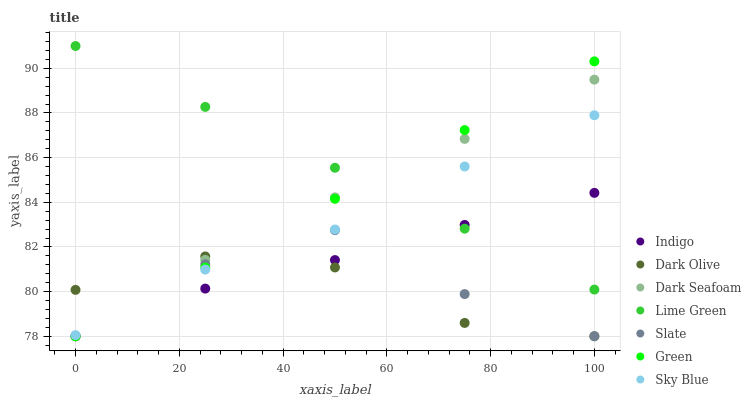Does Dark Olive have the minimum area under the curve?
Answer yes or no. Yes. Does Lime Green have the maximum area under the curve?
Answer yes or no. Yes. Does Slate have the minimum area under the curve?
Answer yes or no. No. Does Slate have the maximum area under the curve?
Answer yes or no. No. Is Green the smoothest?
Answer yes or no. Yes. Is Slate the roughest?
Answer yes or no. Yes. Is Dark Olive the smoothest?
Answer yes or no. No. Is Dark Olive the roughest?
Answer yes or no. No. Does Indigo have the lowest value?
Answer yes or no. Yes. Does Sky Blue have the lowest value?
Answer yes or no. No. Does Lime Green have the highest value?
Answer yes or no. Yes. Does Slate have the highest value?
Answer yes or no. No. Is Slate less than Lime Green?
Answer yes or no. Yes. Is Lime Green greater than Dark Olive?
Answer yes or no. Yes. Does Dark Seafoam intersect Sky Blue?
Answer yes or no. Yes. Is Dark Seafoam less than Sky Blue?
Answer yes or no. No. Is Dark Seafoam greater than Sky Blue?
Answer yes or no. No. Does Slate intersect Lime Green?
Answer yes or no. No. 